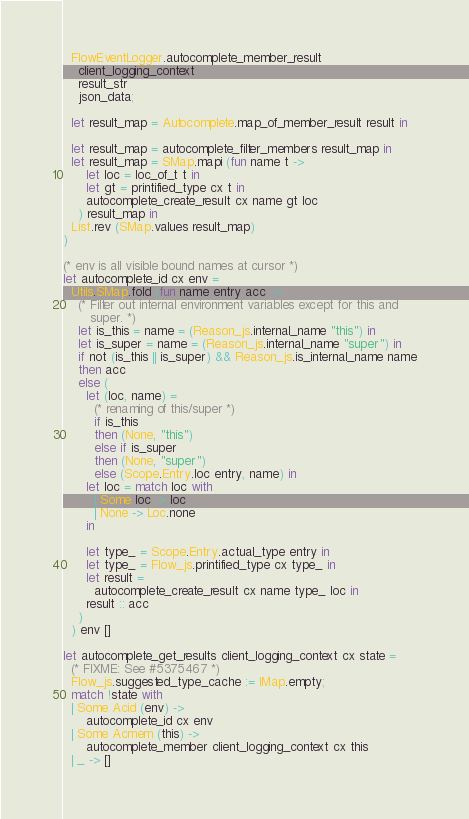Convert code to text. <code><loc_0><loc_0><loc_500><loc_500><_OCaml_>  FlowEventLogger.autocomplete_member_result
    client_logging_context
    result_str
    json_data;

  let result_map = Autocomplete.map_of_member_result result in

  let result_map = autocomplete_filter_members result_map in
  let result_map = SMap.mapi (fun name t ->
      let loc = loc_of_t t in
      let gt = printified_type cx t in
      autocomplete_create_result cx name gt loc
    ) result_map in
  List.rev (SMap.values result_map)
)

(* env is all visible bound names at cursor *)
let autocomplete_id cx env =
  Utils.SMap.fold (fun name entry acc ->
    (* Filter out internal environment variables except for this and
       super. *)
    let is_this = name = (Reason_js.internal_name "this") in
    let is_super = name = (Reason_js.internal_name "super") in
    if not (is_this || is_super) && Reason_js.is_internal_name name
    then acc
    else (
      let (loc, name) =
        (* renaming of this/super *)
        if is_this
        then (None, "this")
        else if is_super
        then (None, "super")
        else (Scope.Entry.loc entry, name) in
      let loc = match loc with
        | Some loc -> loc
        | None -> Loc.none
      in

      let type_ = Scope.Entry.actual_type entry in
      let type_ = Flow_js.printified_type cx type_ in
      let result =
        autocomplete_create_result cx name type_ loc in
      result :: acc
    )
  ) env []

let autocomplete_get_results client_logging_context cx state =
  (* FIXME: See #5375467 *)
  Flow_js.suggested_type_cache := IMap.empty;
  match !state with
  | Some Acid (env) ->
      autocomplete_id cx env
  | Some Acmem (this) ->
      autocomplete_member client_logging_context cx this
  | _ -> []
</code> 